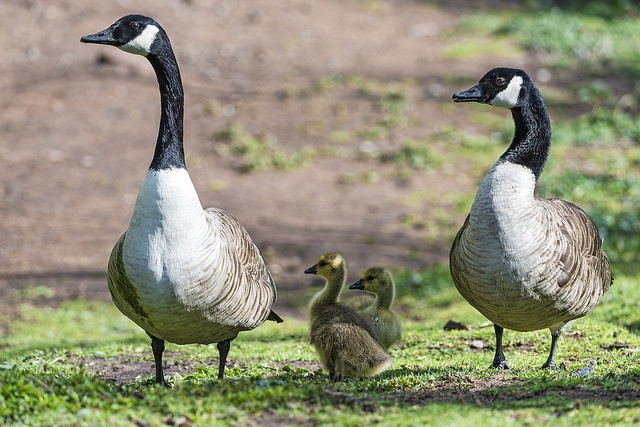Describe the objects in this image and their specific colors. I can see bird in darkgray, lightgray, black, gray, and darkgreen tones, bird in darkgray, lightgray, gray, black, and darkgreen tones, bird in darkgray, black, darkgreen, and gray tones, and bird in darkgray, gray, darkgreen, black, and olive tones in this image. 